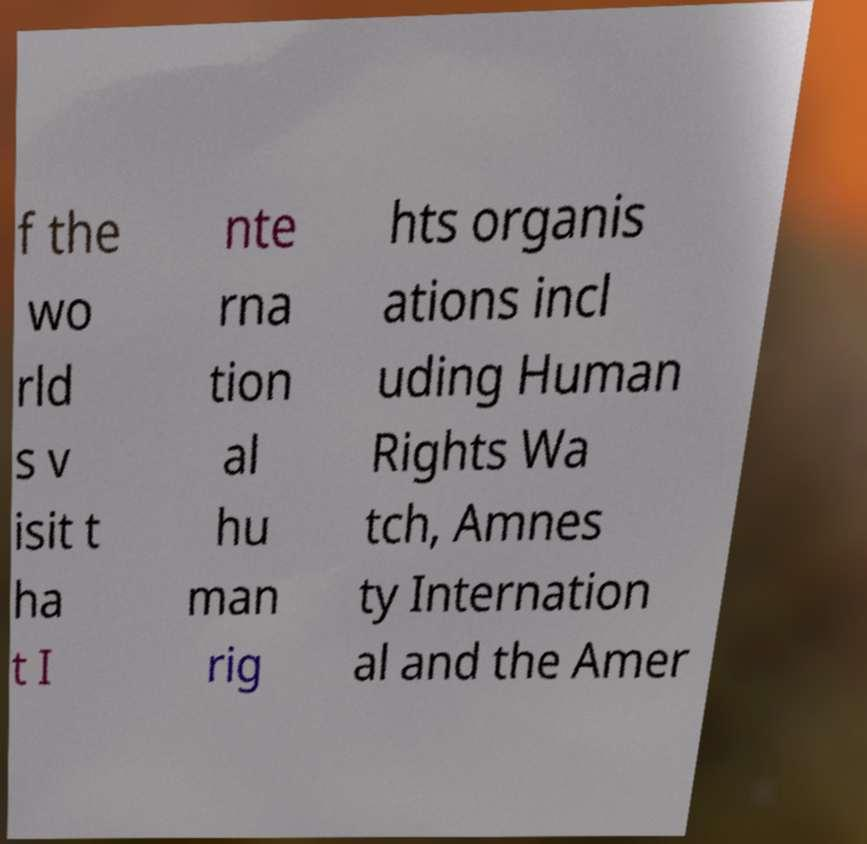Can you read and provide the text displayed in the image?This photo seems to have some interesting text. Can you extract and type it out for me? f the wo rld s v isit t ha t I nte rna tion al hu man rig hts organis ations incl uding Human Rights Wa tch, Amnes ty Internation al and the Amer 